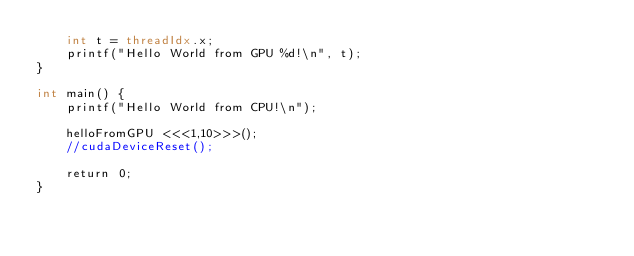<code> <loc_0><loc_0><loc_500><loc_500><_Cuda_>    int t = threadIdx.x;
    printf("Hello World from GPU %d!\n", t);
}

int main() {
    printf("Hello World from CPU!\n");

    helloFromGPU <<<1,10>>>();
    //cudaDeviceReset();

    return 0;
}</code> 